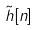<formula> <loc_0><loc_0><loc_500><loc_500>\tilde { h } [ n ]</formula> 